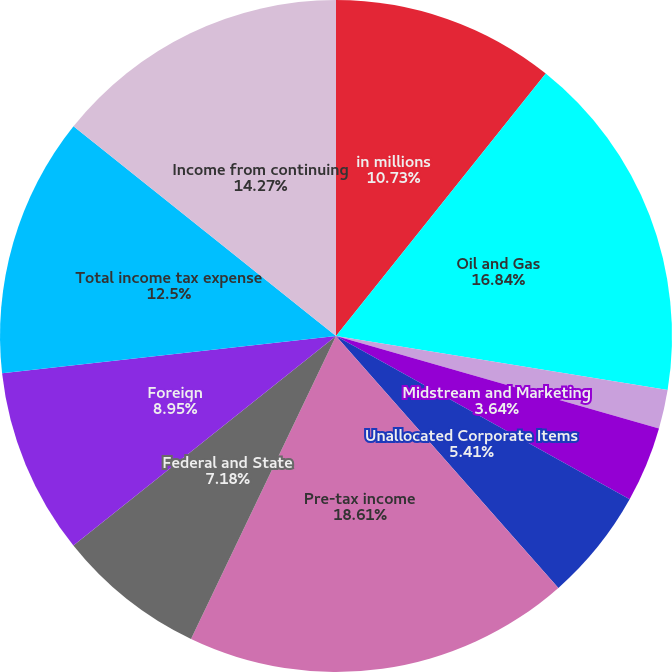Convert chart to OTSL. <chart><loc_0><loc_0><loc_500><loc_500><pie_chart><fcel>in millions<fcel>Oil and Gas<fcel>Chemical<fcel>Midstream and Marketing<fcel>Unallocated Corporate Items<fcel>Pre-tax income<fcel>Federal and State<fcel>Foreign<fcel>Total income tax expense<fcel>Income from continuing<nl><fcel>10.73%<fcel>16.84%<fcel>1.87%<fcel>3.64%<fcel>5.41%<fcel>18.61%<fcel>7.18%<fcel>8.95%<fcel>12.5%<fcel>14.27%<nl></chart> 